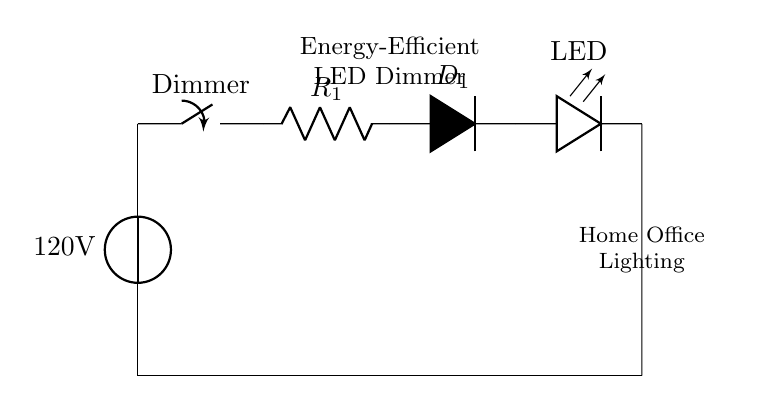What is the voltage source in this circuit? The circuit has a voltage source labeled as 120 volts, which is shown at the beginning of the circuit diagram. This indicates the electric potential supplied to the circuit.
Answer: 120 volts What component is used to control the brightness of the LED? The brightness of the LED is controlled by a component labeled as a dimmer switch. This switch regulates the amount of current flowing to the LED, thus adjusting the brightness.
Answer: Dimmer switch What does the diode do in this circuit? The diode, labeled as D1, allows current to flow in one direction only, providing protection to the LED from reverse voltage which could damage it.
Answer: Protects the LED How many components are connected in series in this circuit? In this circuit, there are five components connected in series: the voltage source, dimmer, resistor, diode, and LED. Following the current path, each component is arranged one after another.
Answer: Five What is the function of resistor R1 in this circuit? The resistor R1 limits the amount of current flowing to the LED, which helps to prevent the LED from drawing too much current and burning out. This ensures that the LED operates efficiently and safely.
Answer: Current limiter What is the purpose of the LED in this circuit? The LED is used to provide light. It emits light when current flows through it, making it suitable for energy-efficient lighting solutions in the home office environment.
Answer: Provides light 